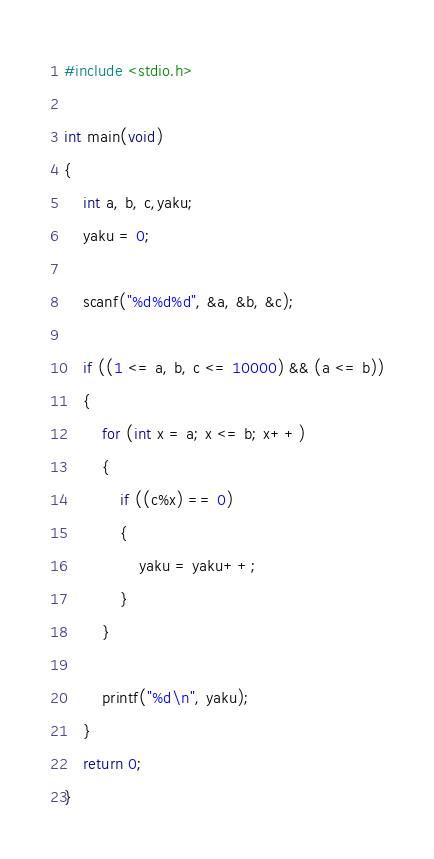<code> <loc_0><loc_0><loc_500><loc_500><_C_>#include <stdio.h>

int main(void)
{
	int a, b, c,yaku;
	yaku = 0;

	scanf("%d%d%d", &a, &b, &c);

	if ((1 <= a, b, c <= 10000) && (a <= b))
	{
		for (int x = a; x <= b; x++)
		{
			if ((c%x) == 0)
			{
				yaku = yaku++;
			}
		}

		printf("%d\n", yaku);
	}
	return 0;
}
</code> 